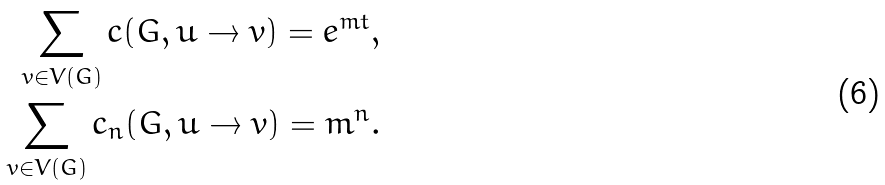Convert formula to latex. <formula><loc_0><loc_0><loc_500><loc_500>\sum _ { v \in V ( G ) } c ( G , u \rightarrow v ) = e ^ { m t } , \\ \sum _ { v \in V ( G ) } c _ { n } ( G , u \rightarrow v ) = m ^ { n } .</formula> 